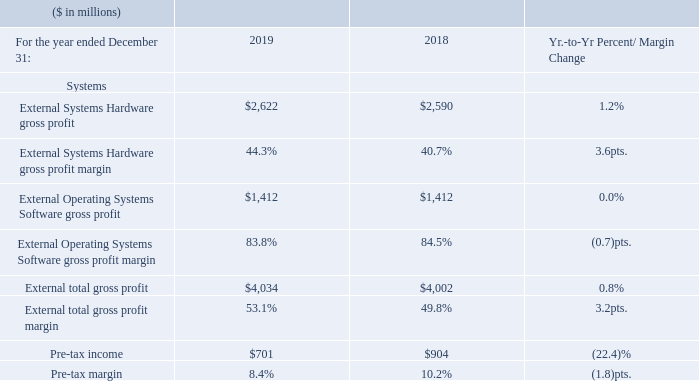The Systems gross profit margin increased 3.2 points to 53.1 percent in 2019 compared to the prior year. The increase was driven by actions taken in 2018 to better position the cost structure over the longer term, a mix to IBM Z hardware and operating systems and margin improvement in Storage Systems.
Pre-tax income of $701 million declined 22.4 percent and pre-tax margin of 8.4 percent decreased 1.8 points year to year driven by the declines in Power Systems and Storage Systems revenue and the continued investment in innovation across the Systems portfolio, mitigated by the benefit from the new hardware launches in the second-half 2019.
What caused the increase in the Systems gross profit margin? The increase was driven by actions taken in 2018 to better position the cost structure over the longer term, a mix to ibm z hardware and operating systems and margin improvement in storage systems. What caused the decrease in the Pre-tax income? Driven by the declines in power systems and storage systems revenue and the continued investment in innovation across the systems portfolio, mitigated by the benefit from the new hardware launches in the second-half 2019. What was the Pre-tax margin in 2019? 8.4%. What was the average External Systems Hardware gross profit?
Answer scale should be: million. (2,622 + 2,590) / 2
Answer: 2606. What is the increase / (decrease) in the External Operating Systems Software gross profit from 2018 to 2019?
Answer scale should be: million. 1,412 - 1,412
Answer: 0. What is the average Pre-tax income?
Answer scale should be: million. (701 + 904) / 2
Answer: 802.5. 